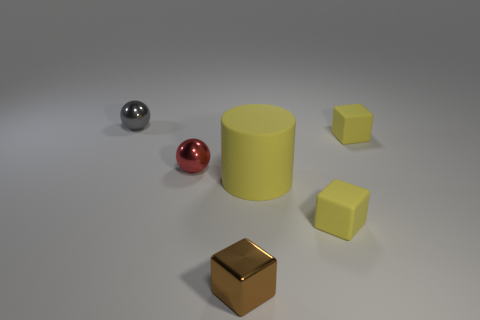Subtract all brown shiny blocks. How many blocks are left? 2 How many yellow blocks must be subtracted to get 1 yellow blocks? 1 Subtract all balls. How many objects are left? 4 Subtract all brown cubes. Subtract all brown balls. How many cubes are left? 2 Subtract all purple balls. How many brown cubes are left? 1 Subtract all tiny brown shiny things. Subtract all tiny matte cubes. How many objects are left? 3 Add 5 small brown things. How many small brown things are left? 6 Add 1 tiny gray balls. How many tiny gray balls exist? 2 Add 3 small brown objects. How many objects exist? 9 Subtract all brown cubes. How many cubes are left? 2 